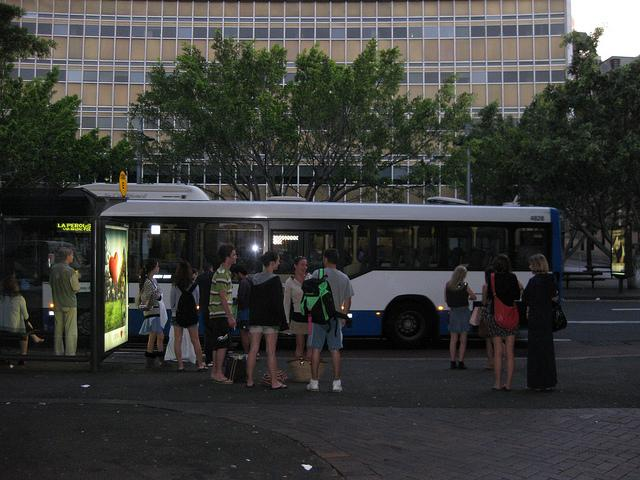Why are they standing on the sidewalk? bus stop 